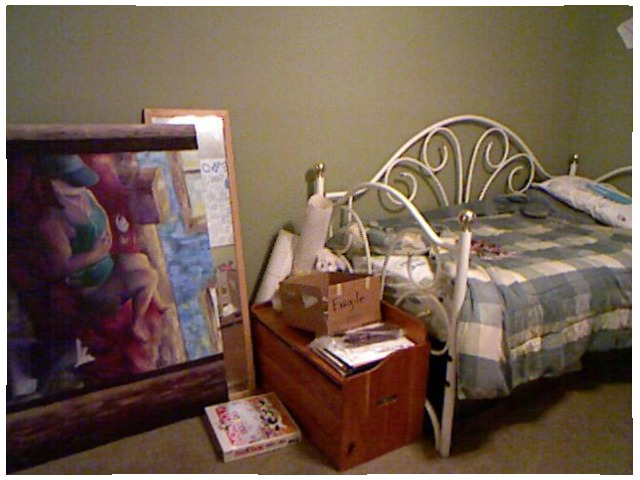<image>
Is the bed behind the table? Yes. From this viewpoint, the bed is positioned behind the table, with the table partially or fully occluding the bed. Where is the game in relation to the comforter? Is it to the left of the comforter? Yes. From this viewpoint, the game is positioned to the left side relative to the comforter. 